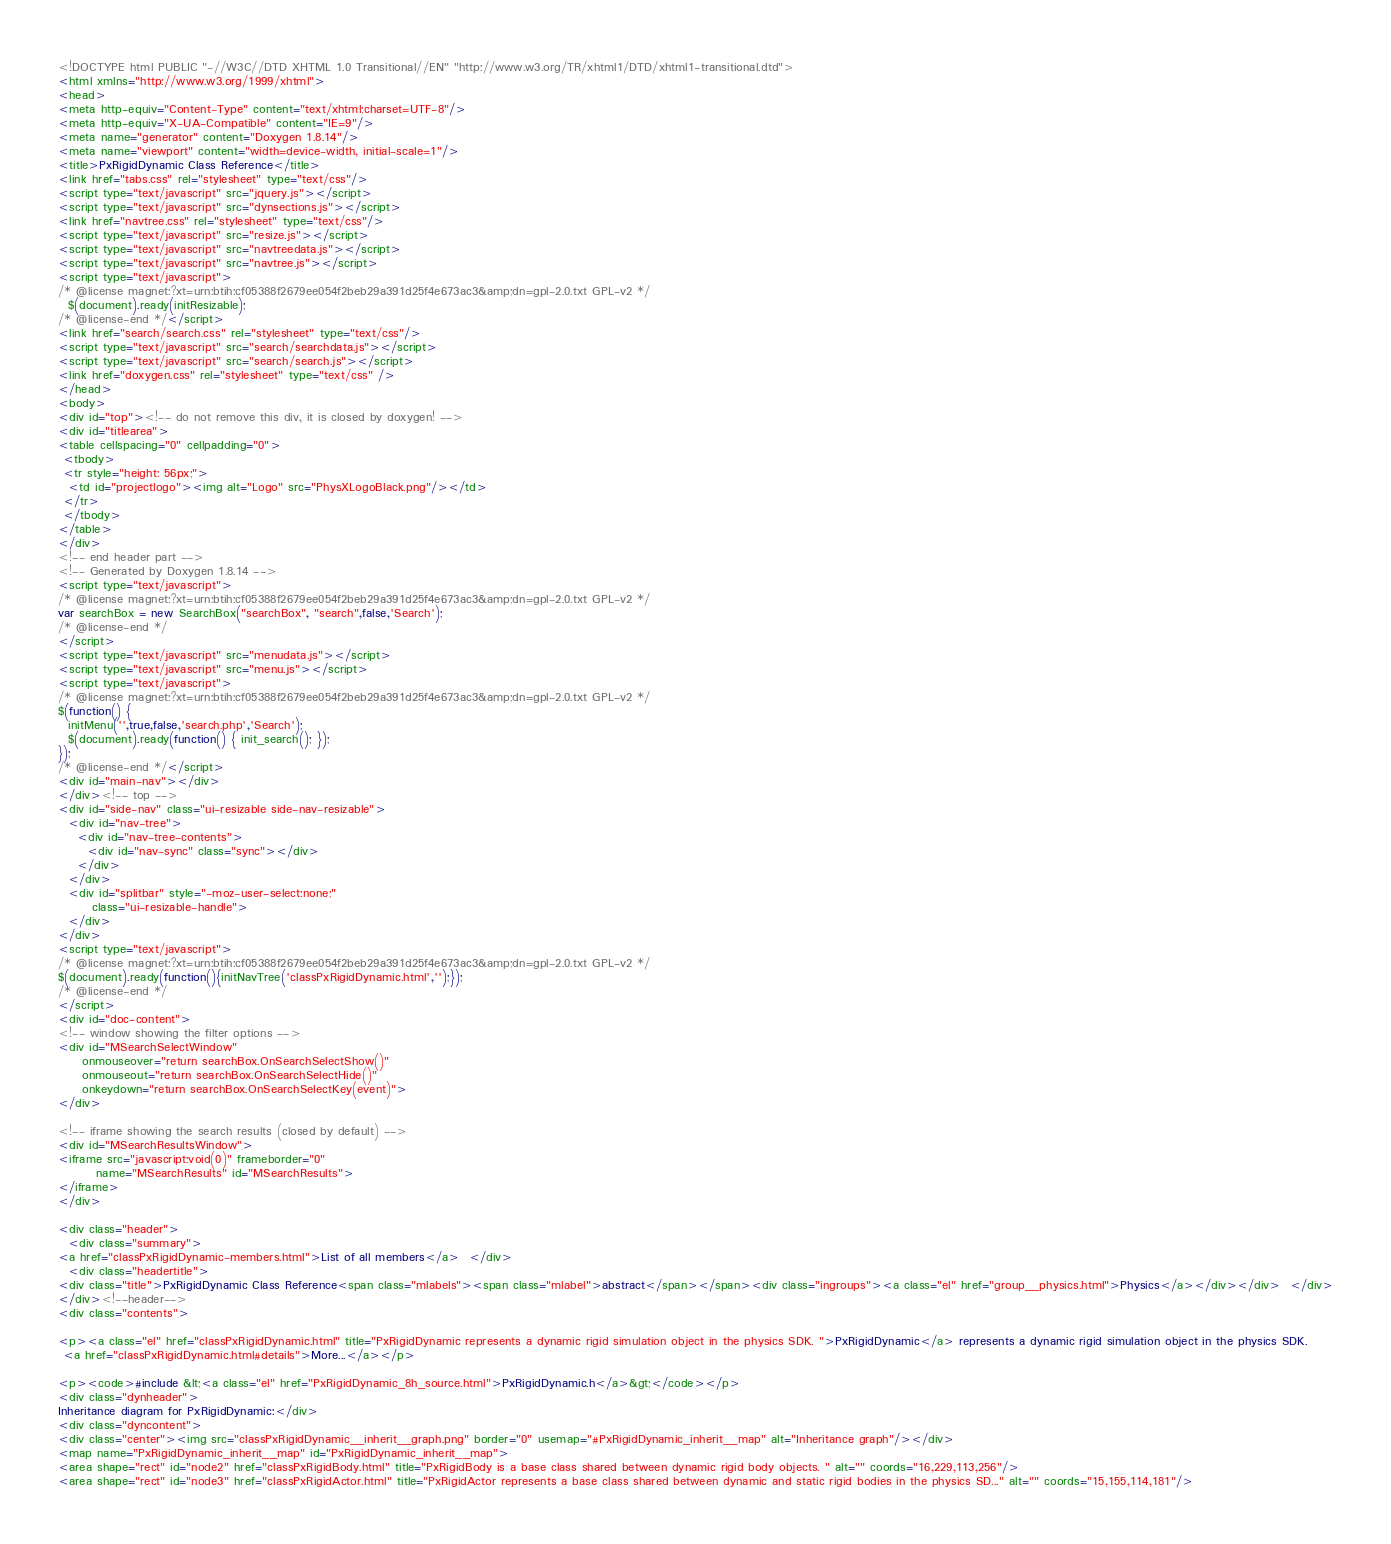Convert code to text. <code><loc_0><loc_0><loc_500><loc_500><_HTML_><!DOCTYPE html PUBLIC "-//W3C//DTD XHTML 1.0 Transitional//EN" "http://www.w3.org/TR/xhtml1/DTD/xhtml1-transitional.dtd">
<html xmlns="http://www.w3.org/1999/xhtml">
<head>
<meta http-equiv="Content-Type" content="text/xhtml;charset=UTF-8"/>
<meta http-equiv="X-UA-Compatible" content="IE=9"/>
<meta name="generator" content="Doxygen 1.8.14"/>
<meta name="viewport" content="width=device-width, initial-scale=1"/>
<title>PxRigidDynamic Class Reference</title>
<link href="tabs.css" rel="stylesheet" type="text/css"/>
<script type="text/javascript" src="jquery.js"></script>
<script type="text/javascript" src="dynsections.js"></script>
<link href="navtree.css" rel="stylesheet" type="text/css"/>
<script type="text/javascript" src="resize.js"></script>
<script type="text/javascript" src="navtreedata.js"></script>
<script type="text/javascript" src="navtree.js"></script>
<script type="text/javascript">
/* @license magnet:?xt=urn:btih:cf05388f2679ee054f2beb29a391d25f4e673ac3&amp;dn=gpl-2.0.txt GPL-v2 */
  $(document).ready(initResizable);
/* @license-end */</script>
<link href="search/search.css" rel="stylesheet" type="text/css"/>
<script type="text/javascript" src="search/searchdata.js"></script>
<script type="text/javascript" src="search/search.js"></script>
<link href="doxygen.css" rel="stylesheet" type="text/css" />
</head>
<body>
<div id="top"><!-- do not remove this div, it is closed by doxygen! -->
<div id="titlearea">
<table cellspacing="0" cellpadding="0">
 <tbody>
 <tr style="height: 56px;">
  <td id="projectlogo"><img alt="Logo" src="PhysXLogoBlack.png"/></td>
 </tr>
 </tbody>
</table>
</div>
<!-- end header part -->
<!-- Generated by Doxygen 1.8.14 -->
<script type="text/javascript">
/* @license magnet:?xt=urn:btih:cf05388f2679ee054f2beb29a391d25f4e673ac3&amp;dn=gpl-2.0.txt GPL-v2 */
var searchBox = new SearchBox("searchBox", "search",false,'Search');
/* @license-end */
</script>
<script type="text/javascript" src="menudata.js"></script>
<script type="text/javascript" src="menu.js"></script>
<script type="text/javascript">
/* @license magnet:?xt=urn:btih:cf05388f2679ee054f2beb29a391d25f4e673ac3&amp;dn=gpl-2.0.txt GPL-v2 */
$(function() {
  initMenu('',true,false,'search.php','Search');
  $(document).ready(function() { init_search(); });
});
/* @license-end */</script>
<div id="main-nav"></div>
</div><!-- top -->
<div id="side-nav" class="ui-resizable side-nav-resizable">
  <div id="nav-tree">
    <div id="nav-tree-contents">
      <div id="nav-sync" class="sync"></div>
    </div>
  </div>
  <div id="splitbar" style="-moz-user-select:none;" 
       class="ui-resizable-handle">
  </div>
</div>
<script type="text/javascript">
/* @license magnet:?xt=urn:btih:cf05388f2679ee054f2beb29a391d25f4e673ac3&amp;dn=gpl-2.0.txt GPL-v2 */
$(document).ready(function(){initNavTree('classPxRigidDynamic.html','');});
/* @license-end */
</script>
<div id="doc-content">
<!-- window showing the filter options -->
<div id="MSearchSelectWindow"
     onmouseover="return searchBox.OnSearchSelectShow()"
     onmouseout="return searchBox.OnSearchSelectHide()"
     onkeydown="return searchBox.OnSearchSelectKey(event)">
</div>

<!-- iframe showing the search results (closed by default) -->
<div id="MSearchResultsWindow">
<iframe src="javascript:void(0)" frameborder="0" 
        name="MSearchResults" id="MSearchResults">
</iframe>
</div>

<div class="header">
  <div class="summary">
<a href="classPxRigidDynamic-members.html">List of all members</a>  </div>
  <div class="headertitle">
<div class="title">PxRigidDynamic Class Reference<span class="mlabels"><span class="mlabel">abstract</span></span><div class="ingroups"><a class="el" href="group__physics.html">Physics</a></div></div>  </div>
</div><!--header-->
<div class="contents">

<p><a class="el" href="classPxRigidDynamic.html" title="PxRigidDynamic represents a dynamic rigid simulation object in the physics SDK. ">PxRigidDynamic</a> represents a dynamic rigid simulation object in the physics SDK.  
 <a href="classPxRigidDynamic.html#details">More...</a></p>

<p><code>#include &lt;<a class="el" href="PxRigidDynamic_8h_source.html">PxRigidDynamic.h</a>&gt;</code></p>
<div class="dynheader">
Inheritance diagram for PxRigidDynamic:</div>
<div class="dyncontent">
<div class="center"><img src="classPxRigidDynamic__inherit__graph.png" border="0" usemap="#PxRigidDynamic_inherit__map" alt="Inheritance graph"/></div>
<map name="PxRigidDynamic_inherit__map" id="PxRigidDynamic_inherit__map">
<area shape="rect" id="node2" href="classPxRigidBody.html" title="PxRigidBody is a base class shared between dynamic rigid body objects. " alt="" coords="16,229,113,256"/>
<area shape="rect" id="node3" href="classPxRigidActor.html" title="PxRigidActor represents a base class shared between dynamic and static rigid bodies in the physics SD..." alt="" coords="15,155,114,181"/></code> 